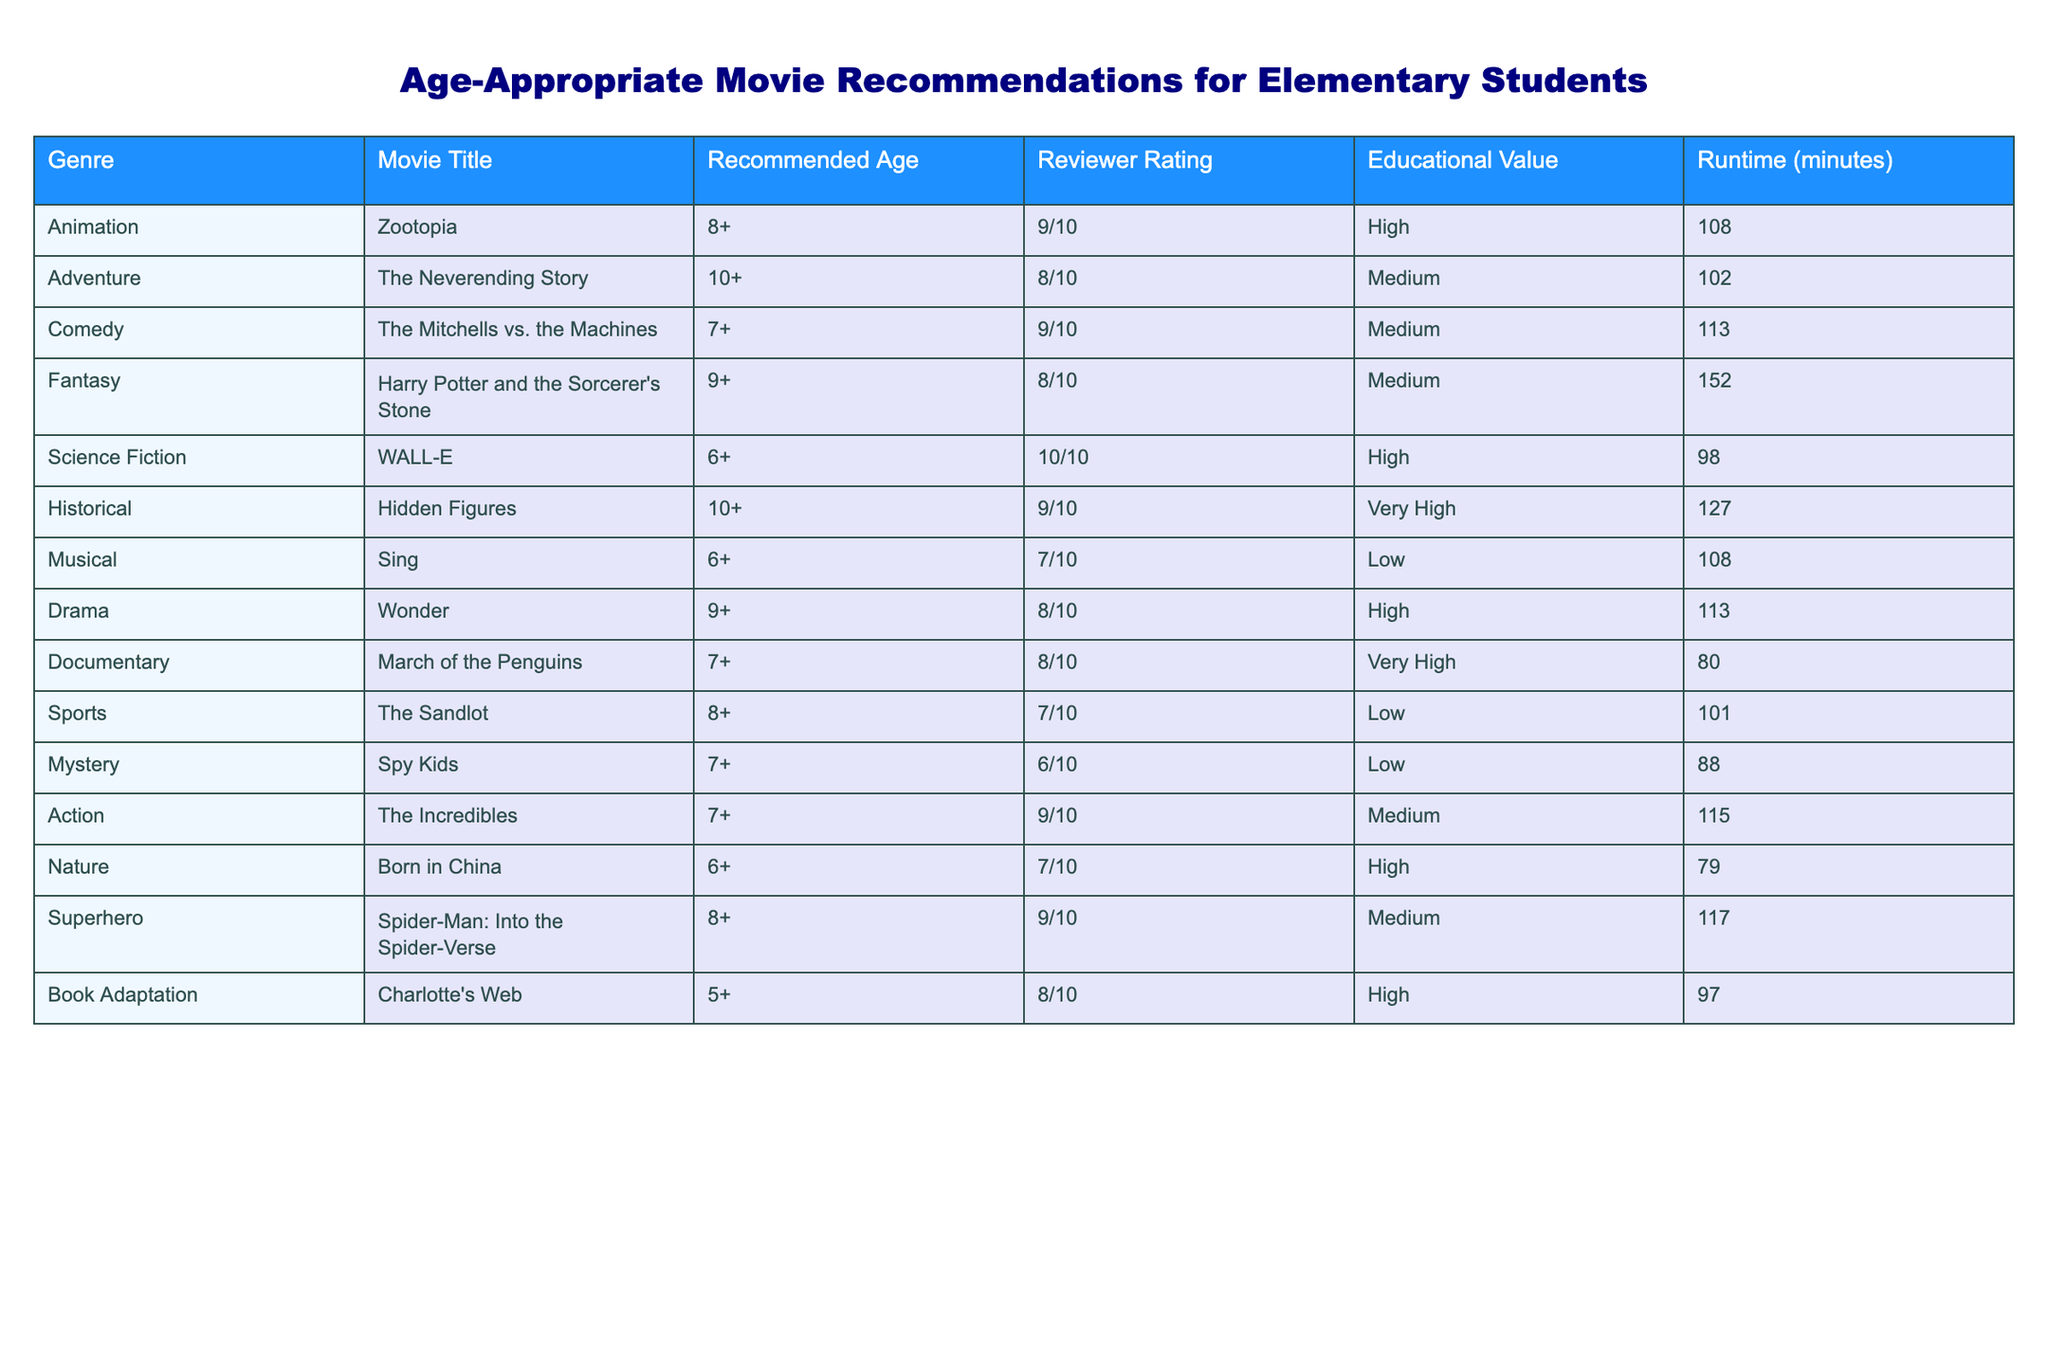What is the recommended age for "Zootopia"? The table lists "Zootopia" under the Animation genre with a recommended age of 8+.
Answer: 8+ Which movie has the highest reviewer rating? The movie "WALL-E" has a reviewer rating of 10/10, which is the highest in the table.
Answer: WALL-E How many movies are recommended for ages 6 and up? The movies recommended for ages 6 and up are "WALL-E", "Sing", "March of the Penguins", and "Born in China", totaling 4 movies.
Answer: 4 Is "Hidden Figures" considered to have high educational value? Yes, "Hidden Figures" is labeled as having very high educational value in the table.
Answer: Yes Which genre has the longest runtime and what is that runtime? The Fantasy genre, represented by "Harry Potter and the Sorcerer's Stone", has the longest runtime of 152 minutes.
Answer: 152 minutes What is the average rating of movies with high educational value? The movies with high educational value are "WALL-E," "Hidden Figures," "Wonder," and "Born in China". Their ratings are 10/10, 9/10, 8/10, and 7/10. The average rating is (10 + 9 + 8 + 7) / 4 = 8.5/10.
Answer: 8.5/10 How many movies in the table have a recommended age of 10+? The movies with a recommended age of 10+ are "The Neverending Story" and "Hidden Figures", totaling 2 movies.
Answer: 2 Are there any superhero movies listed? Yes, "Spider-Man: Into the Spider-Verse" is listed under the Superhero genre in the table.
Answer: Yes Which movie is a book adaptation and what is its recommended age? "Charlotte's Web" is the book adaptation listed with a recommended age of 5+.
Answer: 5+ What is the total runtime of all the movies recommended for ages 7 and up? The runtimes of the movies for ages 7 and up are: "The Mitchells vs. the Machines" (113), "The Neverending Story" (102), "Harry Potter and the Sorcerer's Stone" (152), "Wonder" (113), "March of the Penguins" (80), "Spy Kids" (88), "The Incredibles" (115), and "Spider-Man: Into the Spider-Verse" (117). Summing these gives 113 + 102 + 152 + 113 + 80 + 88 + 115 + 117 = 880 minutes.
Answer: 880 minutes 